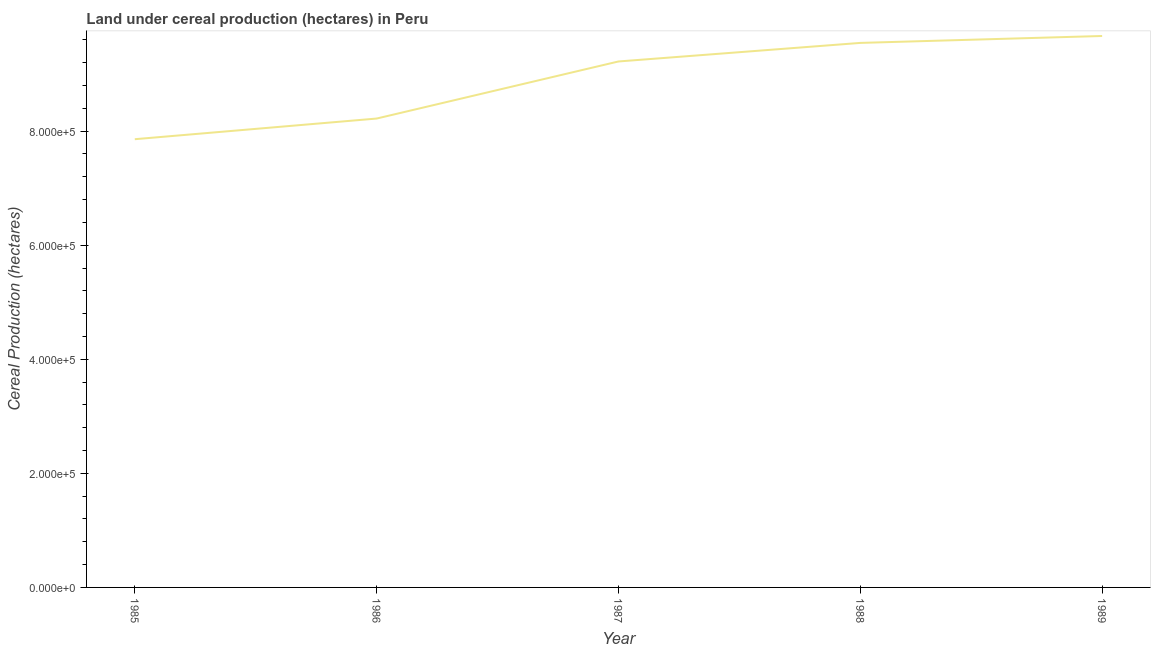What is the land under cereal production in 1989?
Offer a very short reply. 9.67e+05. Across all years, what is the maximum land under cereal production?
Offer a terse response. 9.67e+05. Across all years, what is the minimum land under cereal production?
Offer a terse response. 7.86e+05. In which year was the land under cereal production maximum?
Your answer should be compact. 1989. In which year was the land under cereal production minimum?
Your answer should be very brief. 1985. What is the sum of the land under cereal production?
Your answer should be very brief. 4.45e+06. What is the difference between the land under cereal production in 1987 and 1988?
Make the answer very short. -3.25e+04. What is the average land under cereal production per year?
Offer a terse response. 8.90e+05. What is the median land under cereal production?
Your answer should be very brief. 9.22e+05. What is the ratio of the land under cereal production in 1986 to that in 1988?
Your response must be concise. 0.86. Is the land under cereal production in 1987 less than that in 1989?
Keep it short and to the point. Yes. Is the difference between the land under cereal production in 1987 and 1988 greater than the difference between any two years?
Offer a very short reply. No. What is the difference between the highest and the second highest land under cereal production?
Offer a very short reply. 1.21e+04. What is the difference between the highest and the lowest land under cereal production?
Provide a short and direct response. 1.81e+05. In how many years, is the land under cereal production greater than the average land under cereal production taken over all years?
Offer a very short reply. 3. What is the difference between two consecutive major ticks on the Y-axis?
Your response must be concise. 2.00e+05. Are the values on the major ticks of Y-axis written in scientific E-notation?
Provide a succinct answer. Yes. What is the title of the graph?
Your answer should be compact. Land under cereal production (hectares) in Peru. What is the label or title of the X-axis?
Provide a succinct answer. Year. What is the label or title of the Y-axis?
Your answer should be compact. Cereal Production (hectares). What is the Cereal Production (hectares) of 1985?
Ensure brevity in your answer.  7.86e+05. What is the Cereal Production (hectares) of 1986?
Offer a terse response. 8.22e+05. What is the Cereal Production (hectares) in 1987?
Your response must be concise. 9.22e+05. What is the Cereal Production (hectares) in 1988?
Your answer should be very brief. 9.55e+05. What is the Cereal Production (hectares) of 1989?
Your answer should be very brief. 9.67e+05. What is the difference between the Cereal Production (hectares) in 1985 and 1986?
Your answer should be very brief. -3.62e+04. What is the difference between the Cereal Production (hectares) in 1985 and 1987?
Offer a terse response. -1.36e+05. What is the difference between the Cereal Production (hectares) in 1985 and 1988?
Ensure brevity in your answer.  -1.69e+05. What is the difference between the Cereal Production (hectares) in 1985 and 1989?
Your answer should be very brief. -1.81e+05. What is the difference between the Cereal Production (hectares) in 1986 and 1987?
Give a very brief answer. -1.00e+05. What is the difference between the Cereal Production (hectares) in 1986 and 1988?
Your response must be concise. -1.33e+05. What is the difference between the Cereal Production (hectares) in 1986 and 1989?
Make the answer very short. -1.45e+05. What is the difference between the Cereal Production (hectares) in 1987 and 1988?
Keep it short and to the point. -3.25e+04. What is the difference between the Cereal Production (hectares) in 1987 and 1989?
Provide a short and direct response. -4.47e+04. What is the difference between the Cereal Production (hectares) in 1988 and 1989?
Ensure brevity in your answer.  -1.21e+04. What is the ratio of the Cereal Production (hectares) in 1985 to that in 1986?
Provide a short and direct response. 0.96. What is the ratio of the Cereal Production (hectares) in 1985 to that in 1987?
Offer a very short reply. 0.85. What is the ratio of the Cereal Production (hectares) in 1985 to that in 1988?
Give a very brief answer. 0.82. What is the ratio of the Cereal Production (hectares) in 1985 to that in 1989?
Make the answer very short. 0.81. What is the ratio of the Cereal Production (hectares) in 1986 to that in 1987?
Provide a short and direct response. 0.89. What is the ratio of the Cereal Production (hectares) in 1986 to that in 1988?
Make the answer very short. 0.86. What is the ratio of the Cereal Production (hectares) in 1987 to that in 1988?
Provide a succinct answer. 0.97. What is the ratio of the Cereal Production (hectares) in 1987 to that in 1989?
Make the answer very short. 0.95. What is the ratio of the Cereal Production (hectares) in 1988 to that in 1989?
Provide a short and direct response. 0.99. 